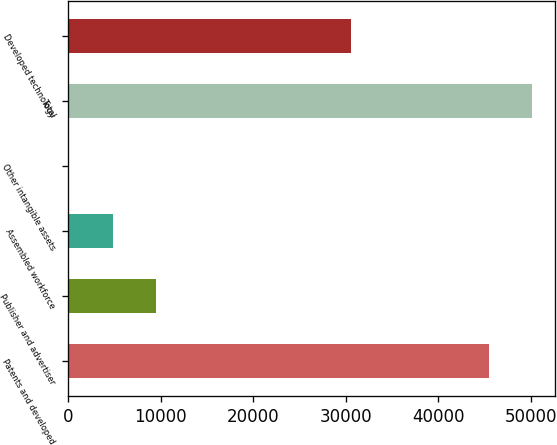Convert chart. <chart><loc_0><loc_0><loc_500><loc_500><bar_chart><fcel>Patents and developed<fcel>Publisher and advertiser<fcel>Assembled workforce<fcel>Other intangible assets<fcel>Total<fcel>Developed technology<nl><fcel>45440<fcel>9495.6<fcel>4796.8<fcel>98<fcel>50138.8<fcel>30556<nl></chart> 